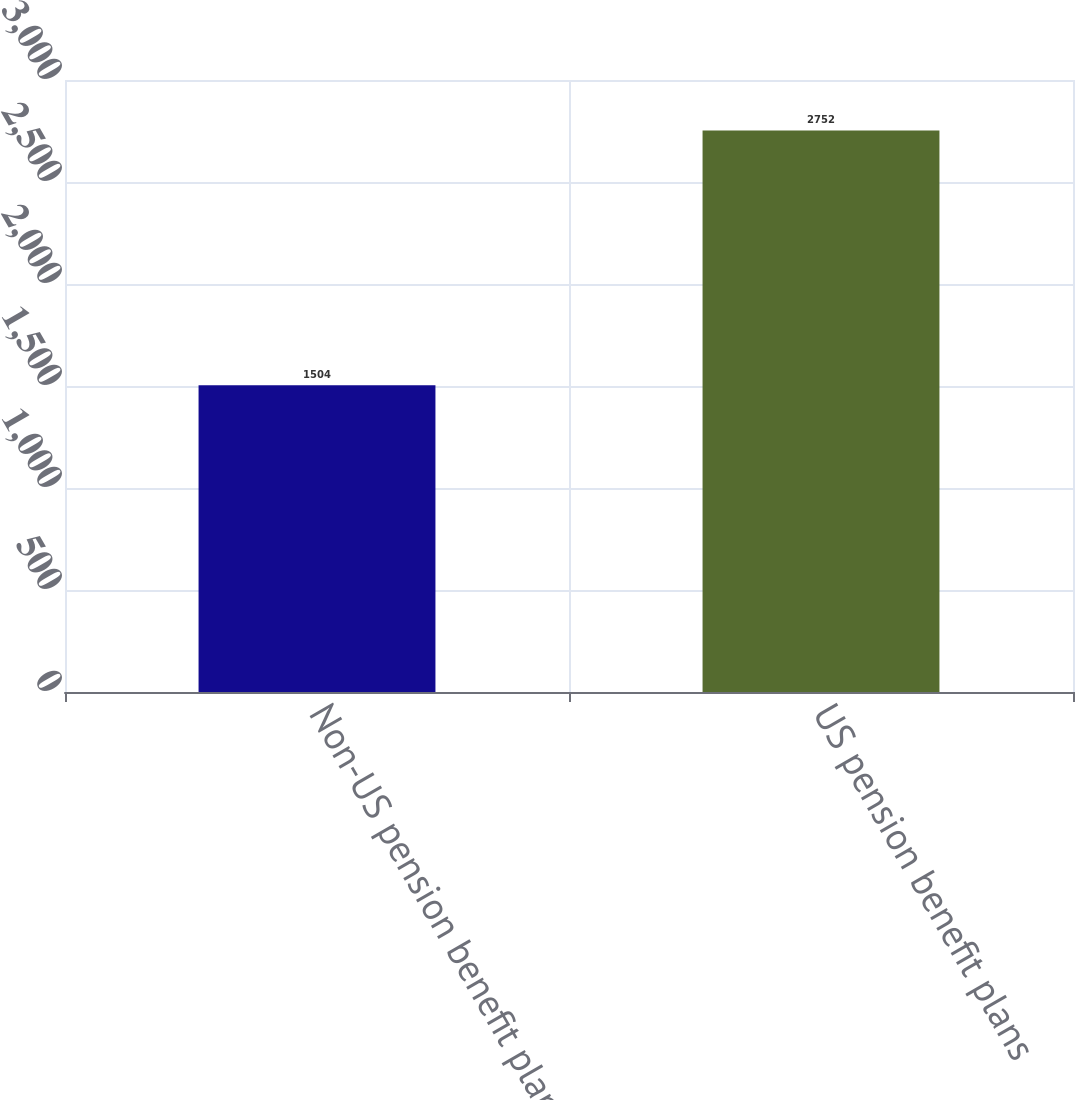Convert chart. <chart><loc_0><loc_0><loc_500><loc_500><bar_chart><fcel>Non-US pension benefit plans<fcel>US pension benefit plans<nl><fcel>1504<fcel>2752<nl></chart> 